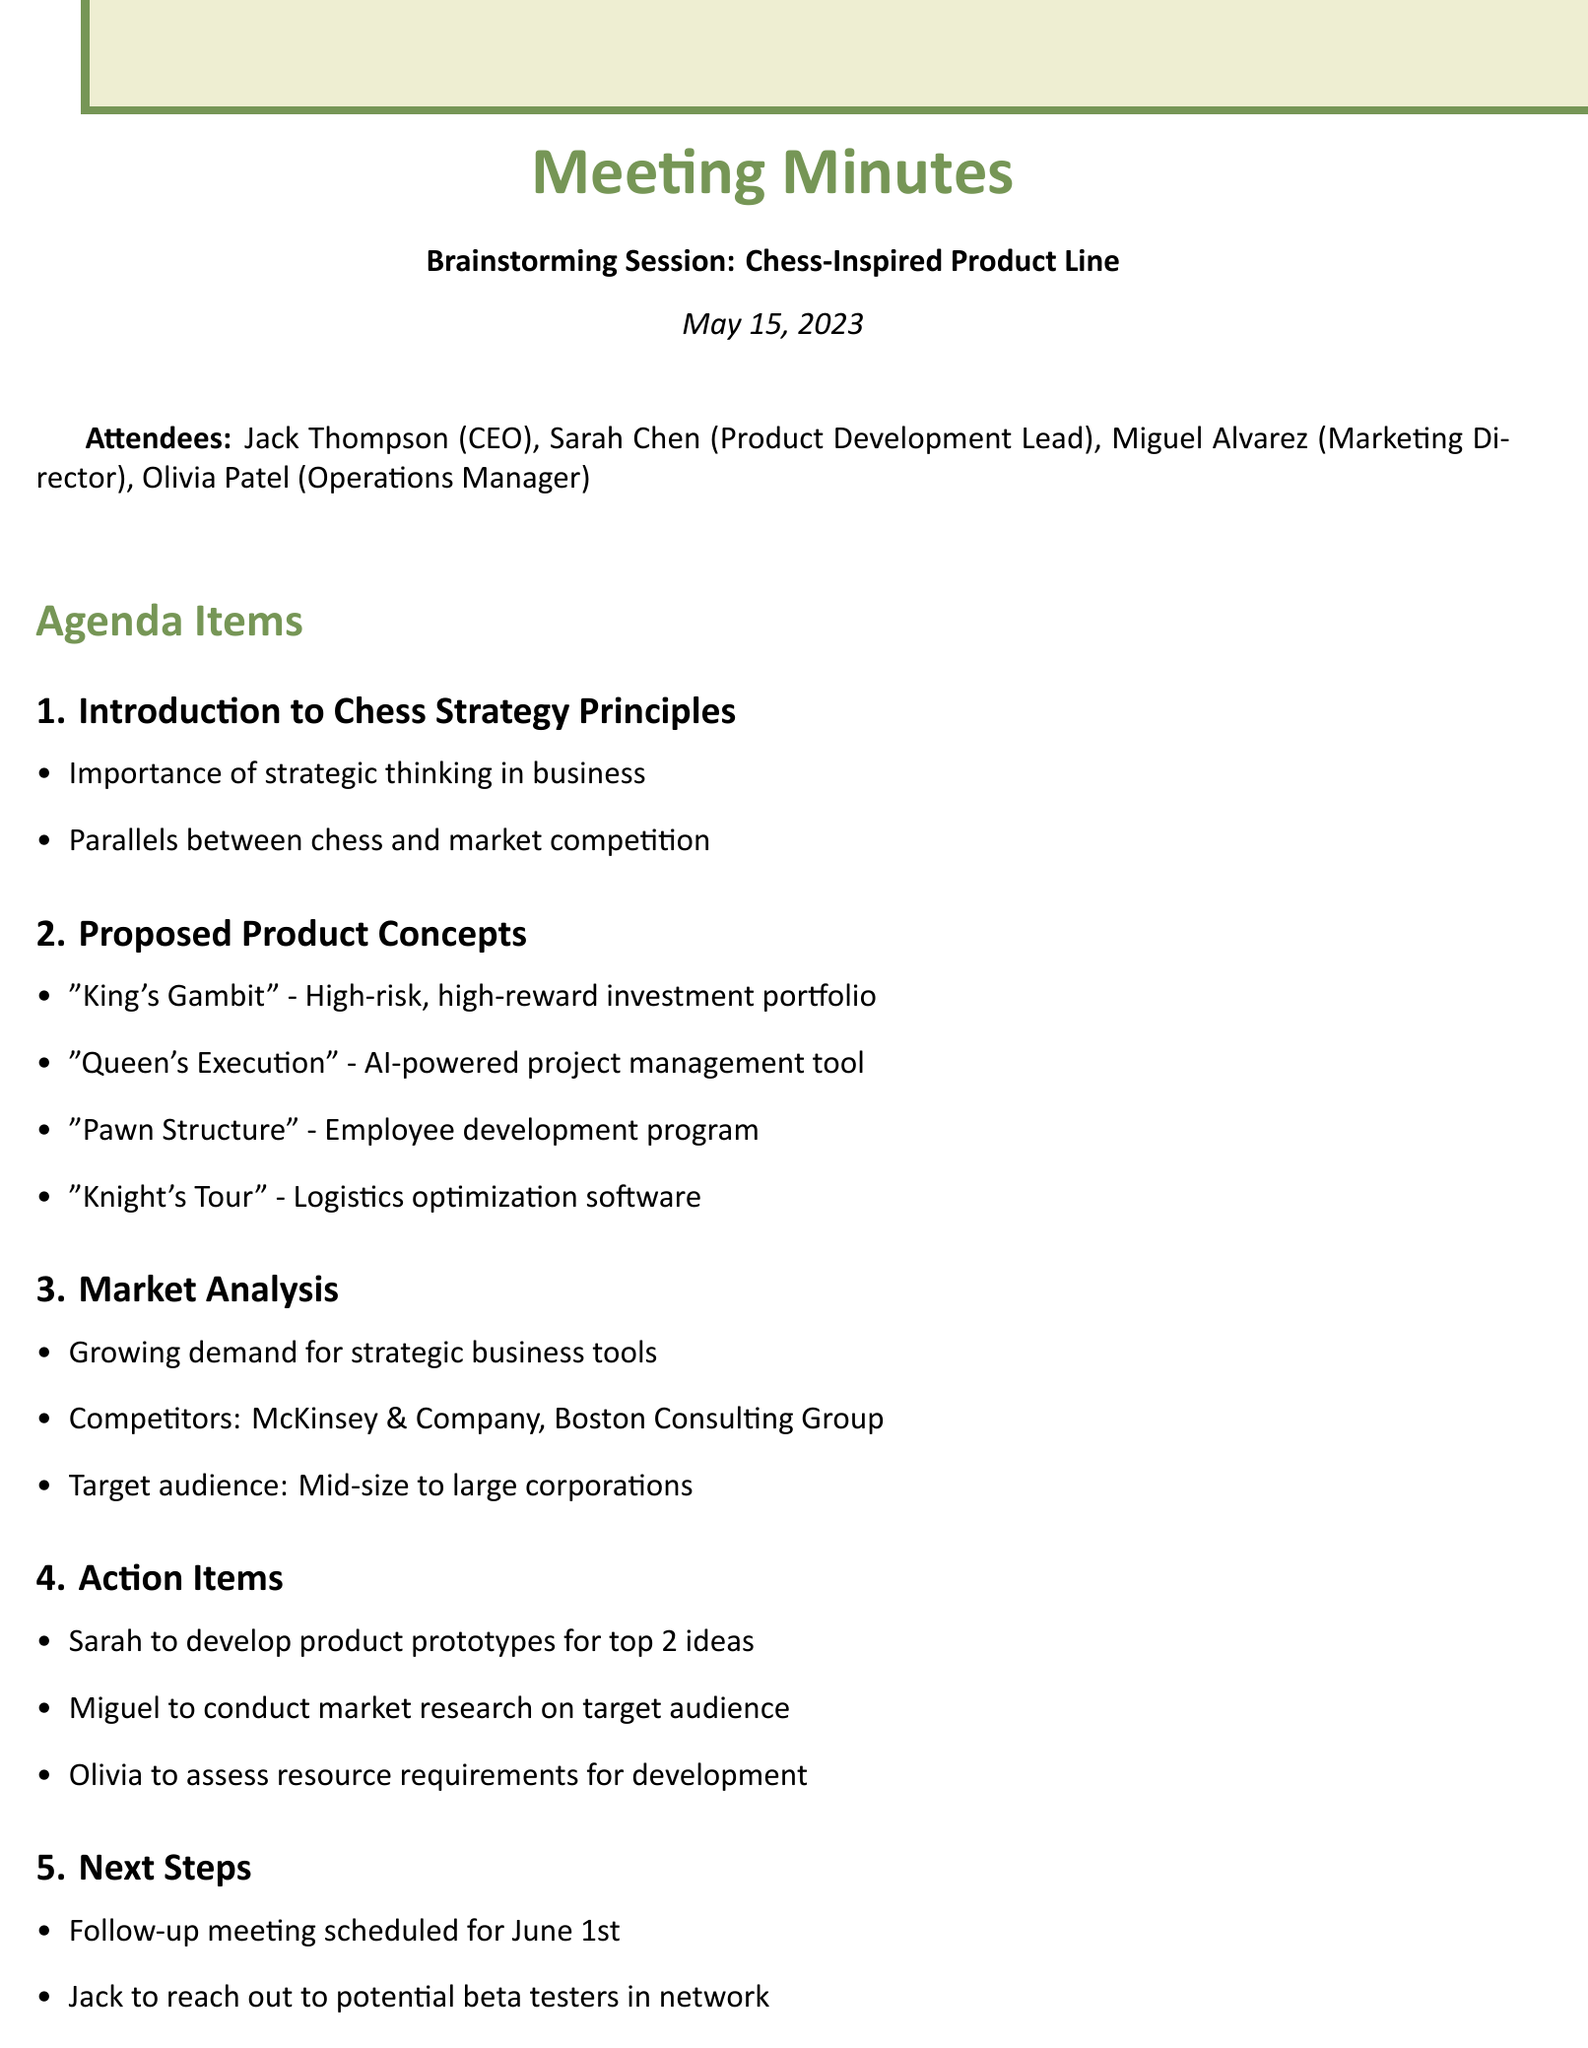What is the meeting title? The meeting title can be found in the header of the document.
Answer: Brainstorming Session: Chess-Inspired Product Line Who is the Product Development Lead? The name and role of the attendees are listed under the attendees section.
Answer: Sarah Chen What is one proposed product concept? The proposed product concepts are listed as items under their respective section.
Answer: "King's Gambit" Which company is a competitor mentioned in the market analysis? Competitors are listed in the market analysis section of the document.
Answer: McKinsey & Company What date is the follow-up meeting scheduled for? The date for the follow-up meeting can be found under the next steps section.
Answer: June 1st Why should we leverage existing business networks? This rationale is included in the key takeaways, encouraging using established connections for support.
Answer: Initial product testing and feedback How many action items were outlined in the document? Counting the tasks under the action items section will provide this information.
Answer: 3 What strategic principle is emphasized in product development? The key takeaways section highlights a major principle discussed during the meeting.
Answer: Strategic thinking 